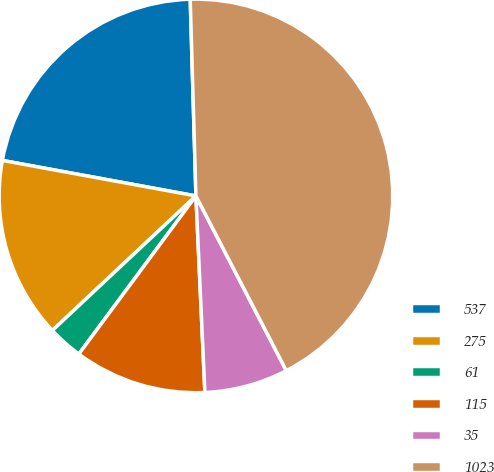Convert chart. <chart><loc_0><loc_0><loc_500><loc_500><pie_chart><fcel>537<fcel>275<fcel>61<fcel>115<fcel>35<fcel>1023<nl><fcel>21.65%<fcel>14.87%<fcel>2.87%<fcel>10.87%<fcel>6.87%<fcel>42.86%<nl></chart> 